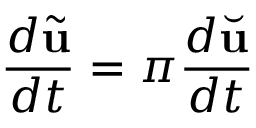<formula> <loc_0><loc_0><loc_500><loc_500>\frac { d \tilde { u } } { d t } = \pi \frac { d \breve { u } } { d t }</formula> 